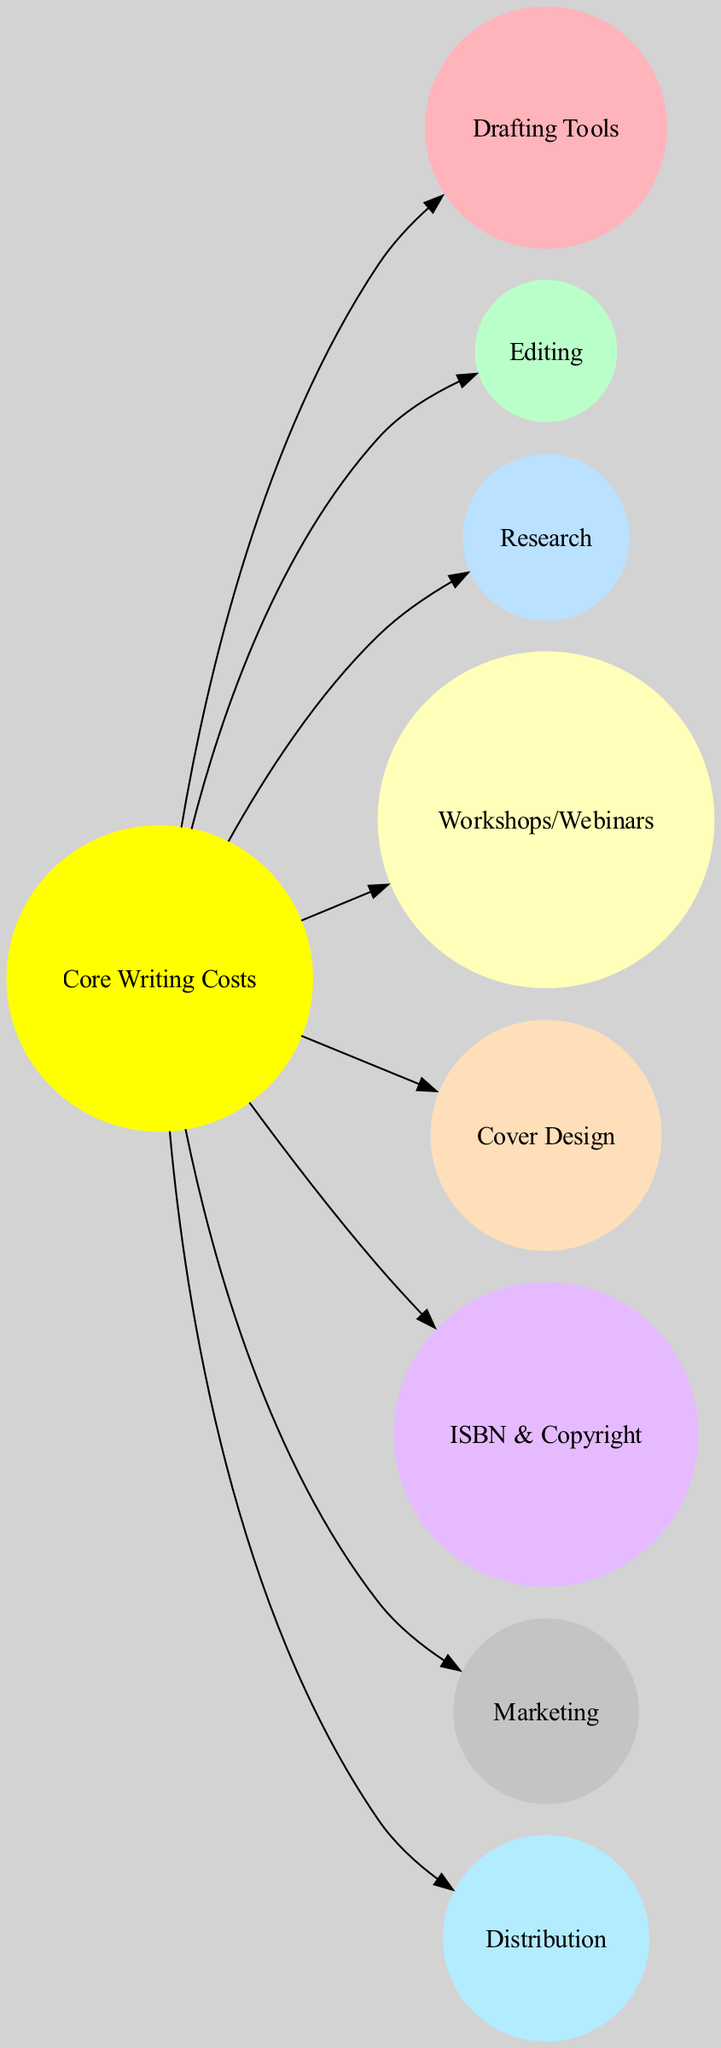What is the name of the central node in the diagram? The central node represents the most crucial expenses related to writing, which is labeled as "Core Writing Costs."
Answer: Core Writing Costs How many planets are depicted in the diagram? The diagram features a total of eight planets represented as costs related to writing projects.
Answer: 8 What are the costs associated with professional editing services called? The planet in the diagram that represents costs for professional editing services is labeled as "Editing."
Answer: Editing Which expense is furthest from the sun in the diagram? To determine this, we look at the planets listed and find that "Distribution" is positioned the furthest from the central node.
Answer: Distribution What expense is categorized under "Moderate Distance"? The diagram lists two expenses at a "Moderate Distance" from the sun: "Research" and "Workshops/Webinars."
Answer: Research, Workshops/Webinars Which planet is related to software and accessories for writing? The expense that corresponds to software and accessories for writing is labeled as "Drafting Tools."
Answer: Drafting Tools What color represents the cost of professional book cover design? The planet labeled "Cover Design" likely uses the fifth color in the specified palette, which corresponds to its position in the arrangement.
Answer: Peach (#FFDFBA) What is the connecting relation between marketing and the sun? The "Marketing" planet is connected to the "Core Writing Costs" node as the budgets for promotional activities serve as an extension of the central writing expenses.
Answer: One edge connecting both nodes 